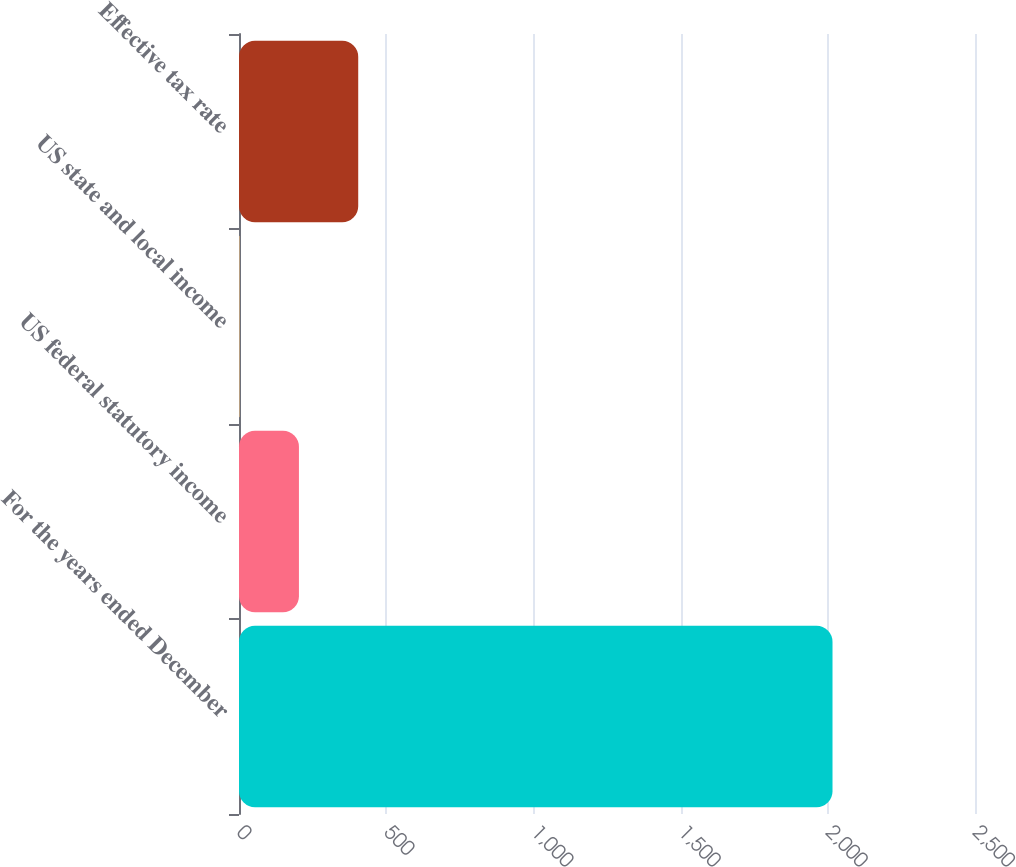Convert chart. <chart><loc_0><loc_0><loc_500><loc_500><bar_chart><fcel>For the years ended December<fcel>US federal statutory income<fcel>US state and local income<fcel>Effective tax rate<nl><fcel>2016<fcel>203.58<fcel>2.2<fcel>404.96<nl></chart> 